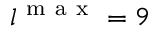<formula> <loc_0><loc_0><loc_500><loc_500>l ^ { m a x } = 9</formula> 